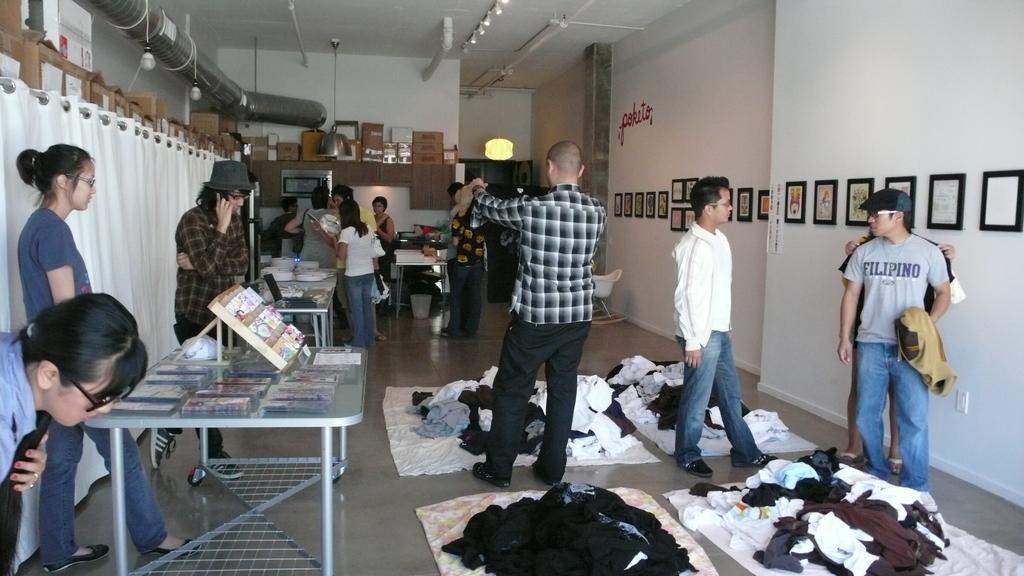Can you describe this image briefly? In this image we can see a group of people standing on the floor. In the foreground we can see some clothes. On the left side of the image we can see curtains, group of objects, plates are placed on tables. In the center of the image we can see a refrigerator, oven and cupboards. On the right side of the image we can see some photo frames on the wall and a chair placed on the floor. In the background, we can see some pipes and lights. 